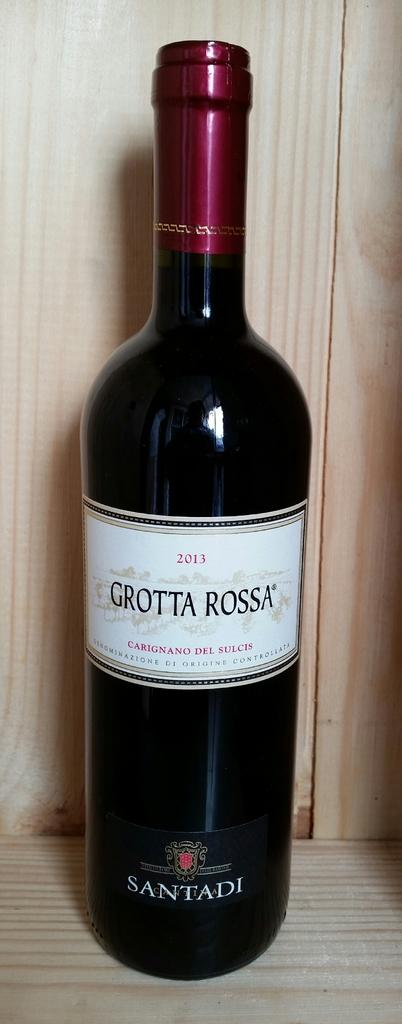Provide a one-sentence caption for the provided image. Bottle of Grotta Rossa placed on a wooden surface. 